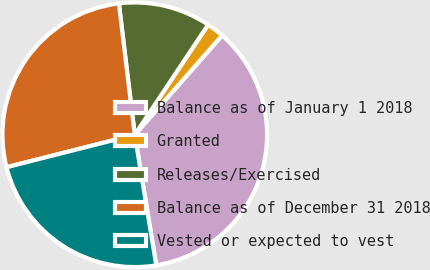Convert chart to OTSL. <chart><loc_0><loc_0><loc_500><loc_500><pie_chart><fcel>Balance as of January 1 2018<fcel>Granted<fcel>Releases/Exercised<fcel>Balance as of December 31 2018<fcel>Vested or expected to vest<nl><fcel>35.92%<fcel>2.12%<fcel>11.27%<fcel>27.03%<fcel>23.65%<nl></chart> 